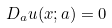Convert formula to latex. <formula><loc_0><loc_0><loc_500><loc_500>D _ { a } u ( x ; a ) = 0</formula> 